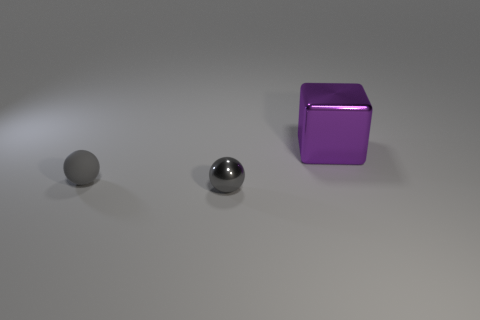Is the size of the ball to the right of the gray matte object the same as the large purple metal cube?
Your answer should be very brief. No. There is a thing that is both in front of the big thing and behind the shiny sphere; what is its shape?
Make the answer very short. Sphere. There is a tiny matte thing; is its color the same as the metal object that is on the left side of the large purple block?
Your answer should be compact. Yes. What color is the thing that is on the right side of the sphere on the right side of the small gray thing on the left side of the shiny ball?
Give a very brief answer. Purple. The other small object that is the same shape as the small gray matte thing is what color?
Give a very brief answer. Gray. Are there the same number of matte things that are to the right of the big thing and gray rubber spheres?
Offer a very short reply. No. What number of cylinders are either metal things or big things?
Offer a terse response. 0. There is a small thing that is the same material as the purple block; what color is it?
Offer a terse response. Gray. Does the big purple block have the same material as the gray thing in front of the tiny rubber ball?
Keep it short and to the point. Yes. How many things are either small green things or gray spheres?
Make the answer very short. 2. 